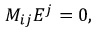<formula> <loc_0><loc_0><loc_500><loc_500>M _ { i j } { E } ^ { j } = 0 ,</formula> 